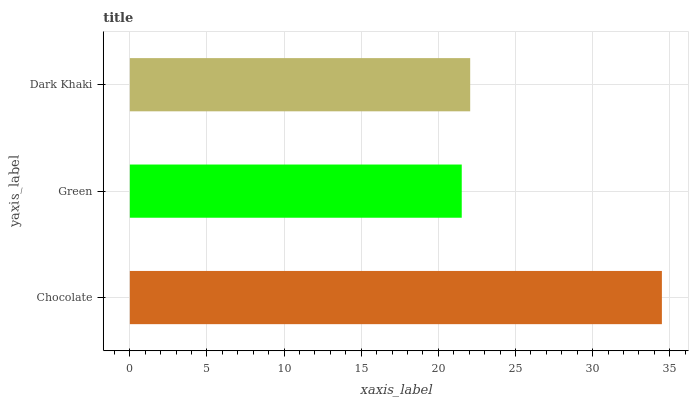Is Green the minimum?
Answer yes or no. Yes. Is Chocolate the maximum?
Answer yes or no. Yes. Is Dark Khaki the minimum?
Answer yes or no. No. Is Dark Khaki the maximum?
Answer yes or no. No. Is Dark Khaki greater than Green?
Answer yes or no. Yes. Is Green less than Dark Khaki?
Answer yes or no. Yes. Is Green greater than Dark Khaki?
Answer yes or no. No. Is Dark Khaki less than Green?
Answer yes or no. No. Is Dark Khaki the high median?
Answer yes or no. Yes. Is Dark Khaki the low median?
Answer yes or no. Yes. Is Chocolate the high median?
Answer yes or no. No. Is Green the low median?
Answer yes or no. No. 